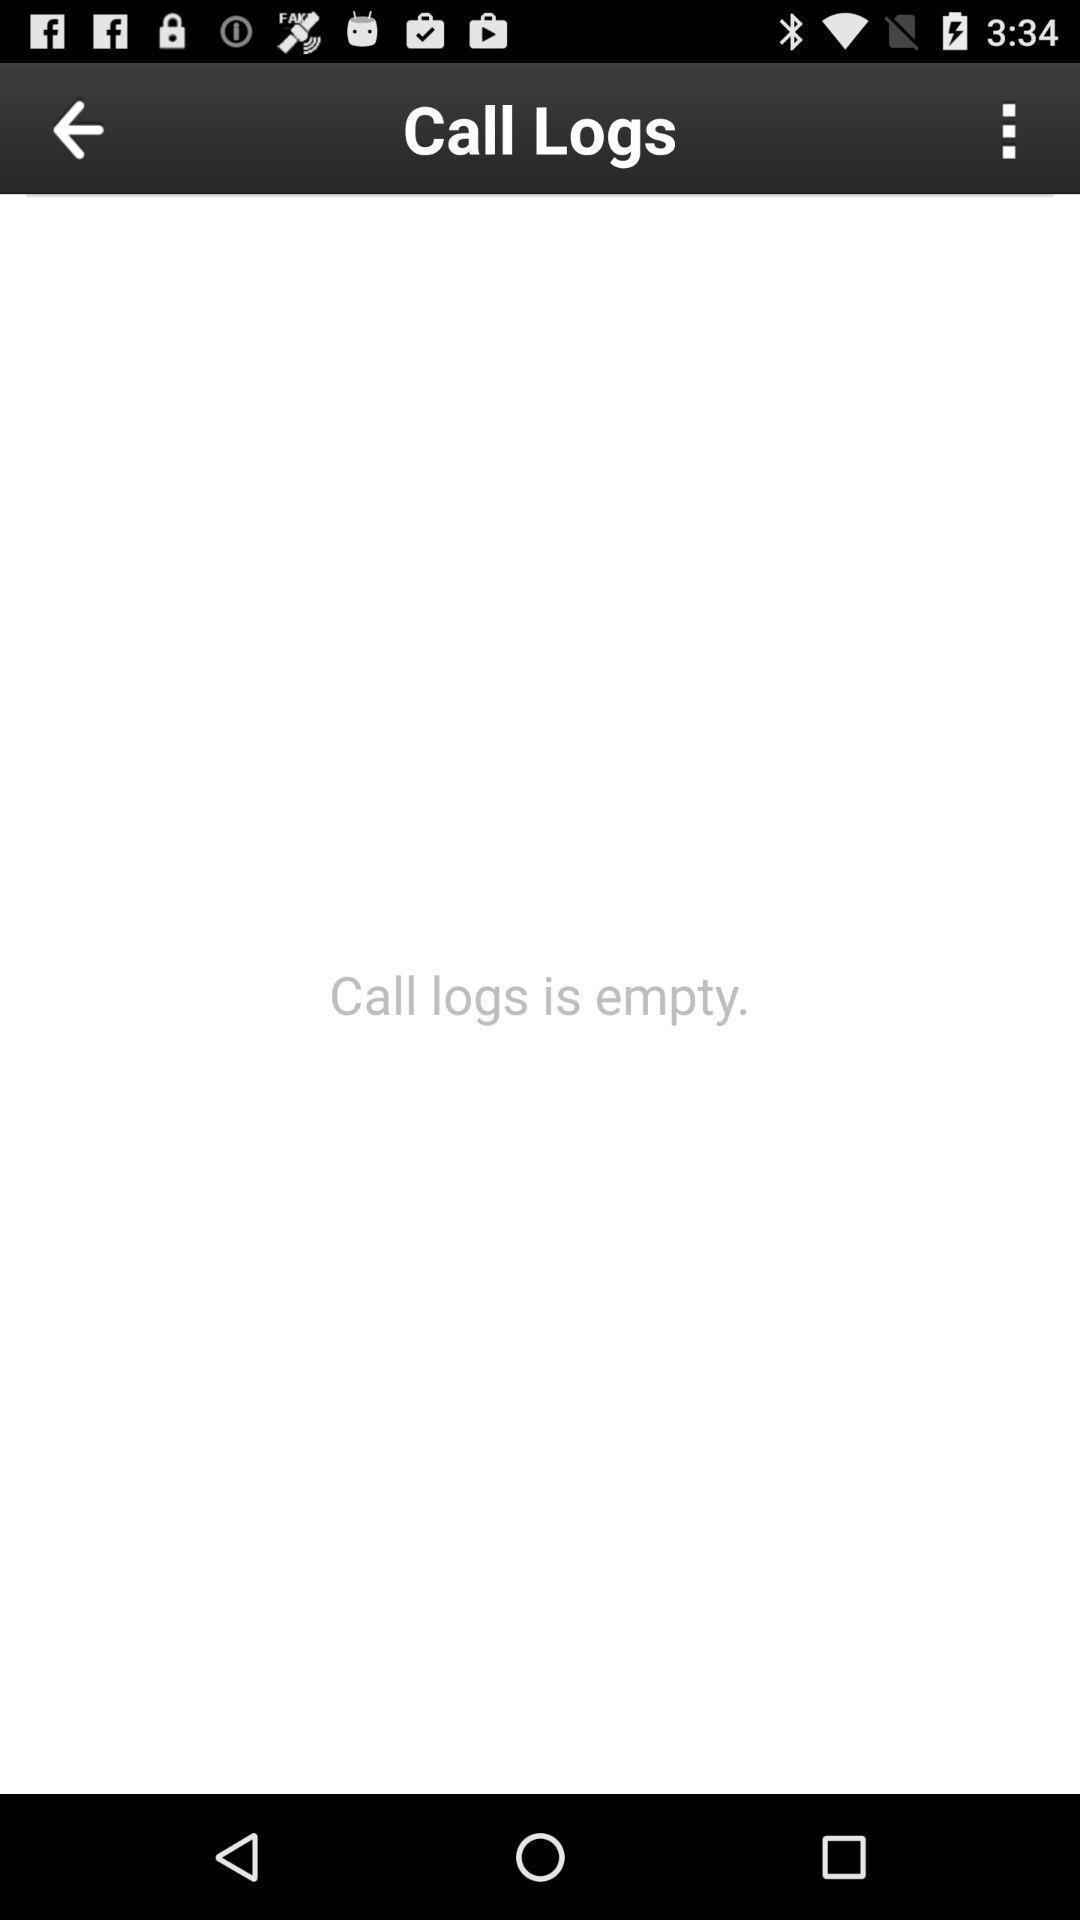Provide a textual representation of this image. Screen displaying calls information with multiple controls. 